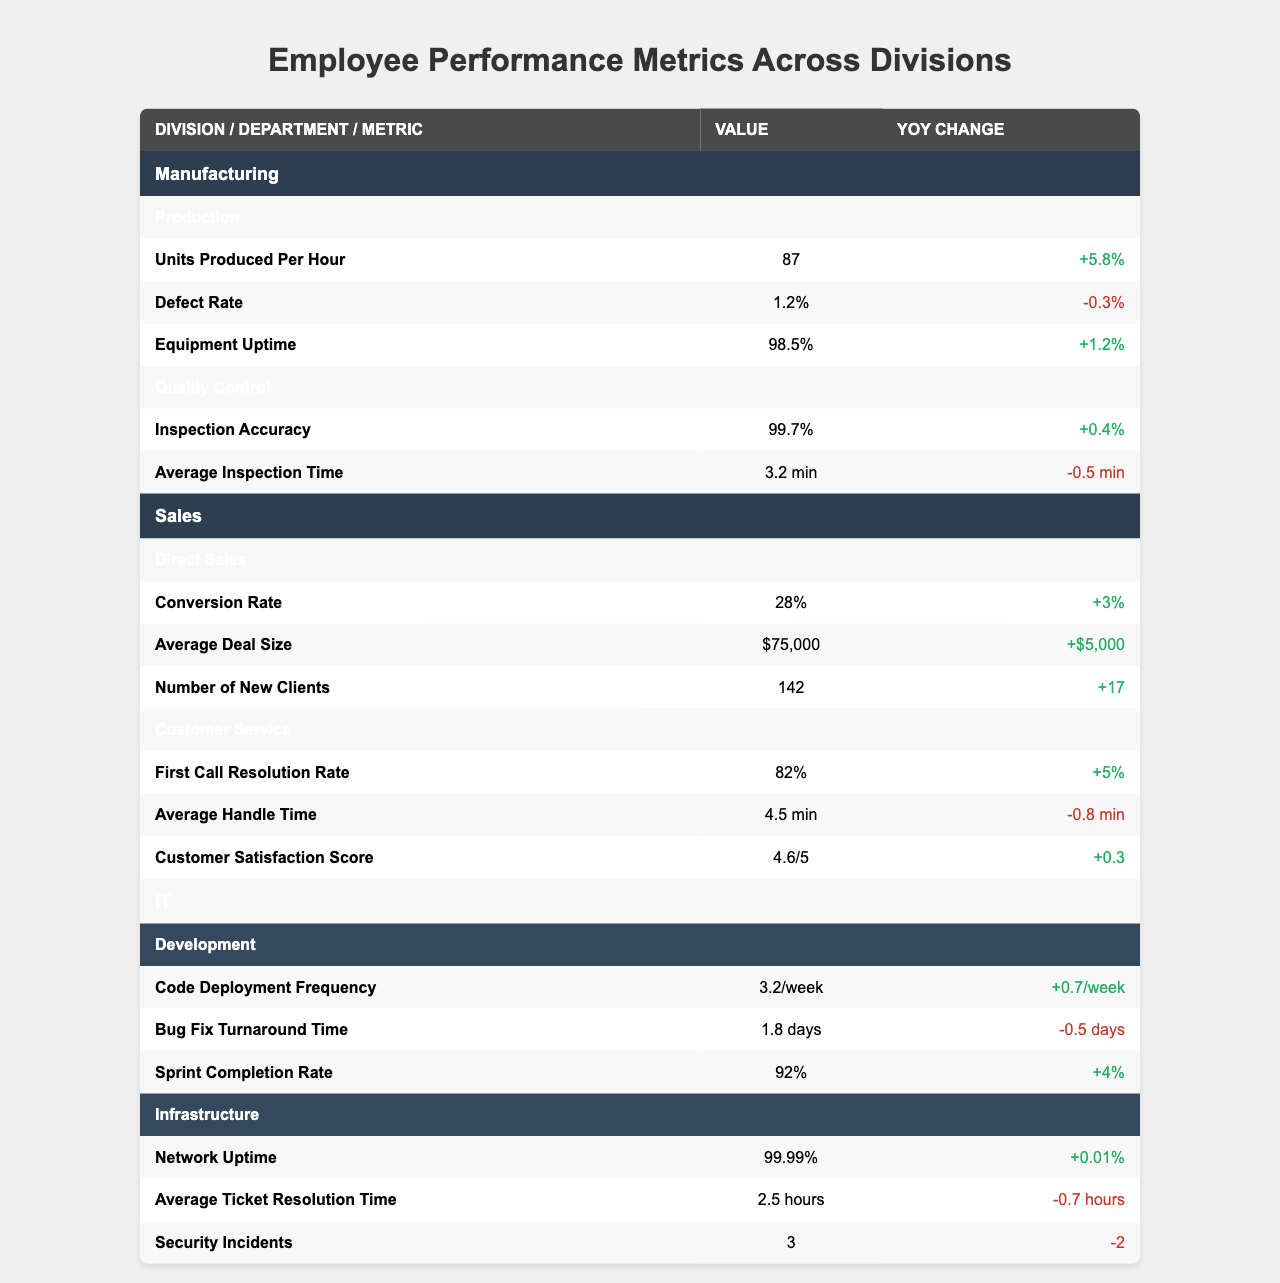What is the highest “Units Produced Per Hour” in the Manufacturing division? The highest value for "Units Produced Per Hour" is listed under the Production department of the Manufacturing division, which is 87.
Answer: 87 What is the average “First Call Resolution Rate” for the Sales division? There is one value for "First Call Resolution Rate" which is 82%, so the average is also 82%.
Answer: 82% What is the “Defect Rate” change percentage from last year? The "Defect Rate" in the Production department of Manufacturing shows a YoY change of -0.3%.
Answer: -0.3% Which department has the highest “Inspection Accuracy”? The Quality Control department in Manufacturing has the highest "Inspection Accuracy" at 99.7%.
Answer: 99.7% Is the “Average Deal Size” in the Sales division increasing or decreasing? The "Average Deal Size" has a YoY Change of +$5,000, indicating it is increasing.
Answer: Increasing How many more “New Clients” did the Sales division acquire compared to the previous year? The number of new clients increased from last year by 17, as indicated in the Direct Sales metrics.
Answer: 17 Which division has the best “Network Uptime”? The Infrastructure department in the IT division reports a "Network Uptime" of 99.99%, which is the highest among all divisions.
Answer: 99.99% What is the average “Average Handle Time” in the Customer Service department? The "Average Handle Time" is 4.5 minutes with only one value provided, so the average remains 4.5 minutes.
Answer: 4.5 min How does the “Average Ticket Resolution Time” compare to the “Bug Fix Turnaround Time”? The "Average Ticket Resolution Time" is 2.5 hours and the "Bug Fix Turnaround Time" is 1.8 days, meaning the ticket resolution time is longer. Converting 1.8 days to hours gives approximately 43.2 hours, indicating ticket resolution is significantly slower.
Answer: Ticket resolution is slower Which division shows the highest improvement in the “Sprint Completion Rate”? The IT Development department has a “Sprint Completion Rate” of 92% with a YoY change of +4%, showing notable improvement.
Answer: 92% 